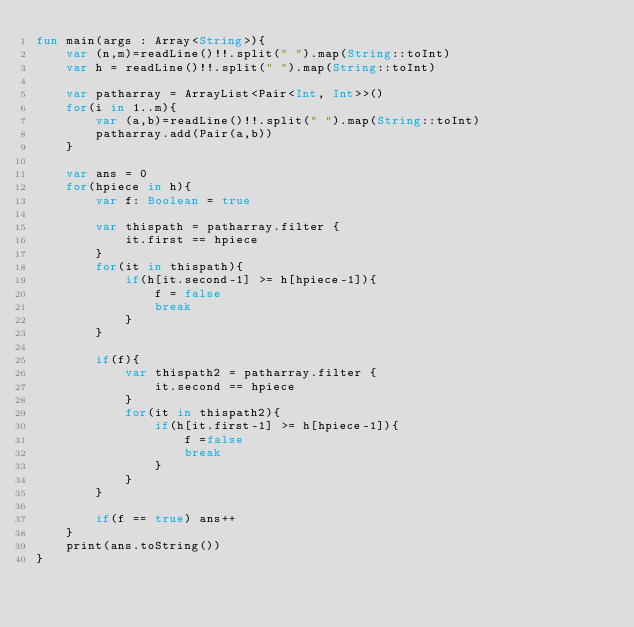Convert code to text. <code><loc_0><loc_0><loc_500><loc_500><_Kotlin_>fun main(args : Array<String>){
    var (n,m)=readLine()!!.split(" ").map(String::toInt)
    var h = readLine()!!.split(" ").map(String::toInt)

    var patharray = ArrayList<Pair<Int, Int>>()
    for(i in 1..m){
        var (a,b)=readLine()!!.split(" ").map(String::toInt)
        patharray.add(Pair(a,b))
    }

    var ans = 0
    for(hpiece in h){
        var f: Boolean = true
        
        var thispath = patharray.filter { 
            it.first == hpiece 
        }
        for(it in thispath){
            if(h[it.second-1] >= h[hpiece-1]){
                f = false
                break
            }
        }

        if(f){
            var thispath2 = patharray.filter { 
                it.second == hpiece 
            }
            for(it in thispath2){
                if(h[it.first-1] >= h[hpiece-1]){
                    f =false
                    break
                }
            }
        }

        if(f == true) ans++
    }
  	print(ans.toString())
}</code> 